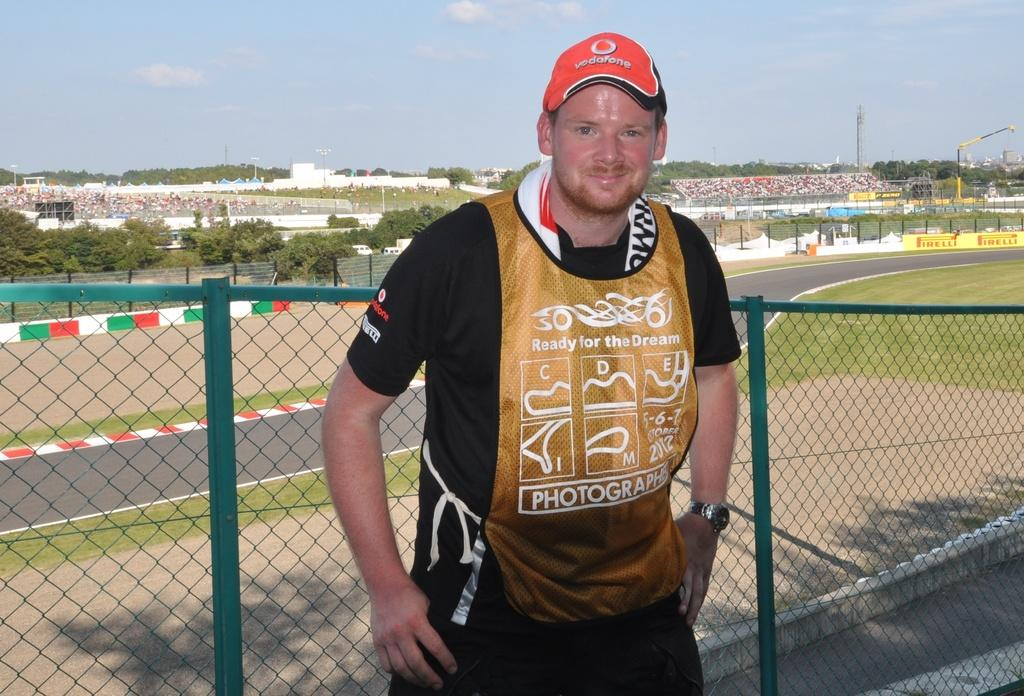<image>
Describe the image concisely. a smiling man in front of a fence wears a red Vodafone hat 